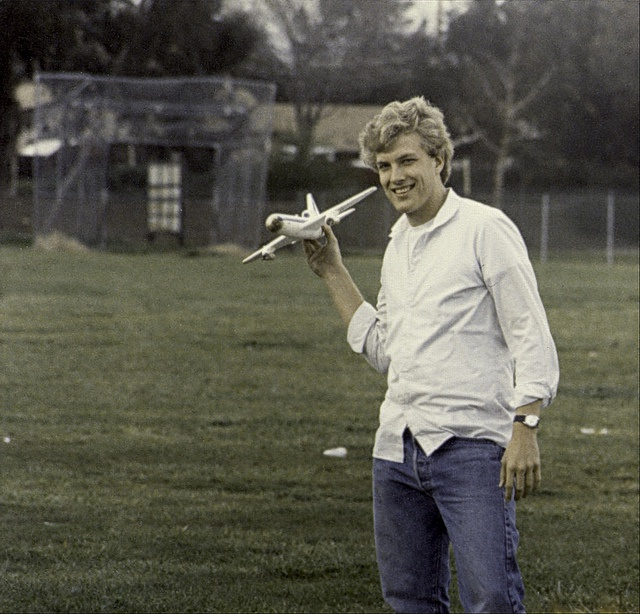Describe the objects in this image and their specific colors. I can see people in black, lightgray, gray, and darkgray tones, airplane in black, beige, darkgray, and gray tones, and clock in black, lightgray, darkgray, and gray tones in this image. 